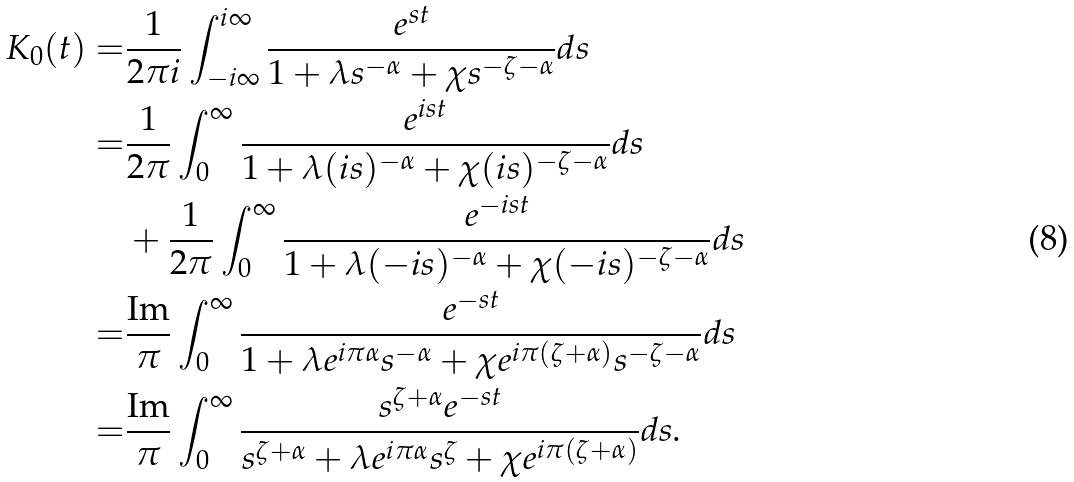Convert formula to latex. <formula><loc_0><loc_0><loc_500><loc_500>K _ { 0 } ( t ) = & \frac { 1 } { 2 \pi i } \int _ { - i \infty } ^ { i \infty } \frac { e ^ { s t } } { 1 + \lambda s ^ { - \alpha } + \chi s ^ { - \zeta - \alpha } } d s \\ = & \frac { 1 } { 2 \pi } \int _ { 0 } ^ { \infty } \frac { e ^ { i s t } } { 1 + \lambda ( i s ) ^ { - \alpha } + \chi ( i s ) ^ { - \zeta - \alpha } } d s \\ & + \frac { 1 } { 2 \pi } \int _ { 0 } ^ { \infty } \frac { e ^ { - i s t } } { 1 + \lambda ( - i s ) ^ { - \alpha } + \chi ( - i s ) ^ { - \zeta - \alpha } } d s \\ = & \frac { \text {Im} } { \pi } \int _ { 0 } ^ { \infty } \frac { e ^ { - s t } } { 1 + \lambda e ^ { i \pi \alpha } s ^ { - \alpha } + \chi e ^ { i \pi ( \zeta + \alpha ) } s ^ { - \zeta - \alpha } } d s \\ = & \frac { \text {Im} } { \pi } \int _ { 0 } ^ { \infty } \frac { s ^ { \zeta + \alpha } e ^ { - s t } } { s ^ { \zeta + \alpha } + \lambda e ^ { i \pi \alpha } s ^ { \zeta } + \chi e ^ { i \pi ( \zeta + \alpha ) } } d s .</formula> 